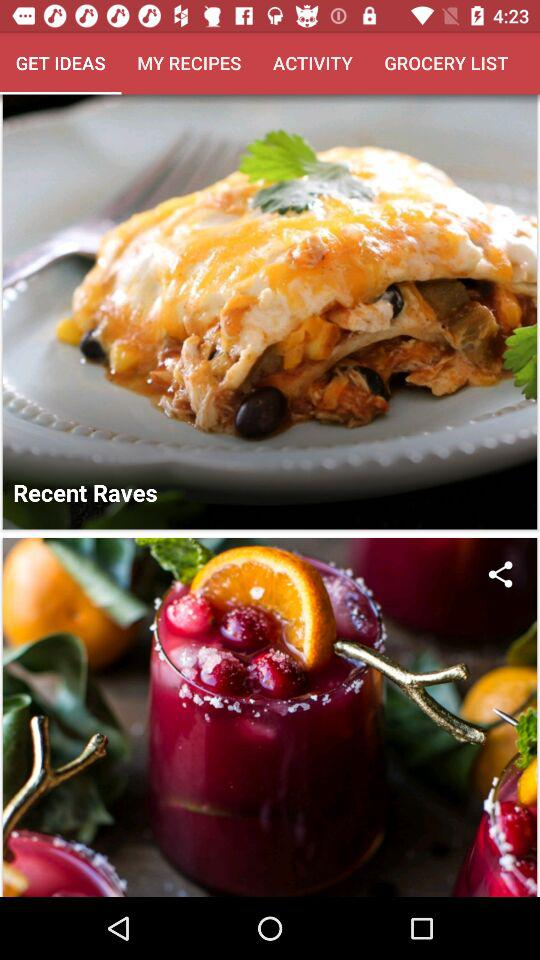Which tab am I on? You are on the "GET IDEAS" tab. 